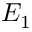Convert formula to latex. <formula><loc_0><loc_0><loc_500><loc_500>E _ { 1 }</formula> 